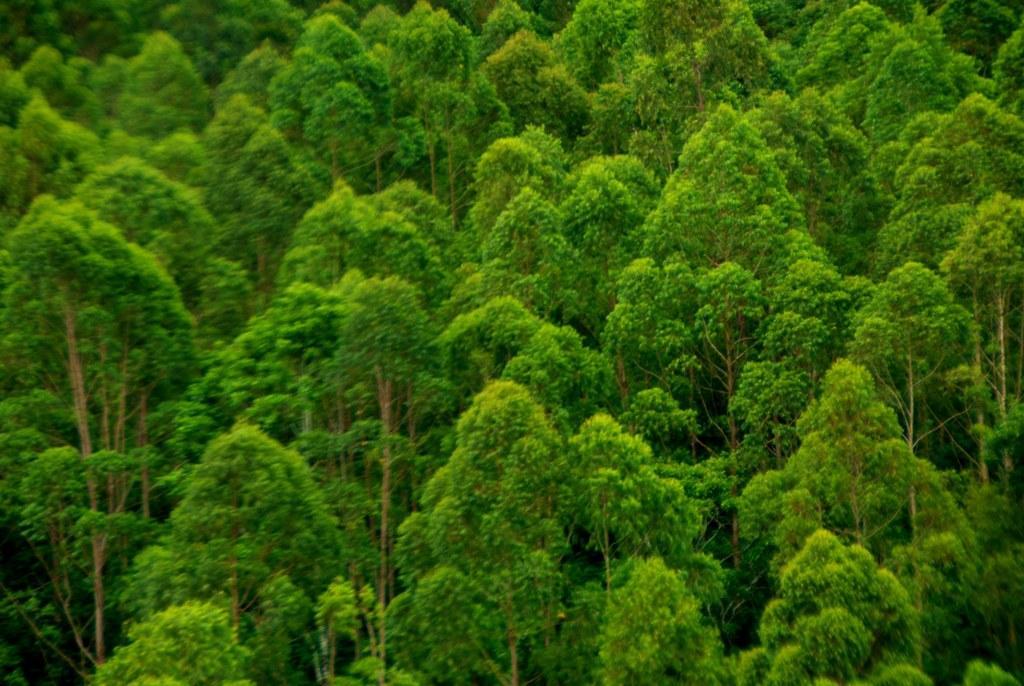Can you describe this image briefly? Here there are many trees in this image. 